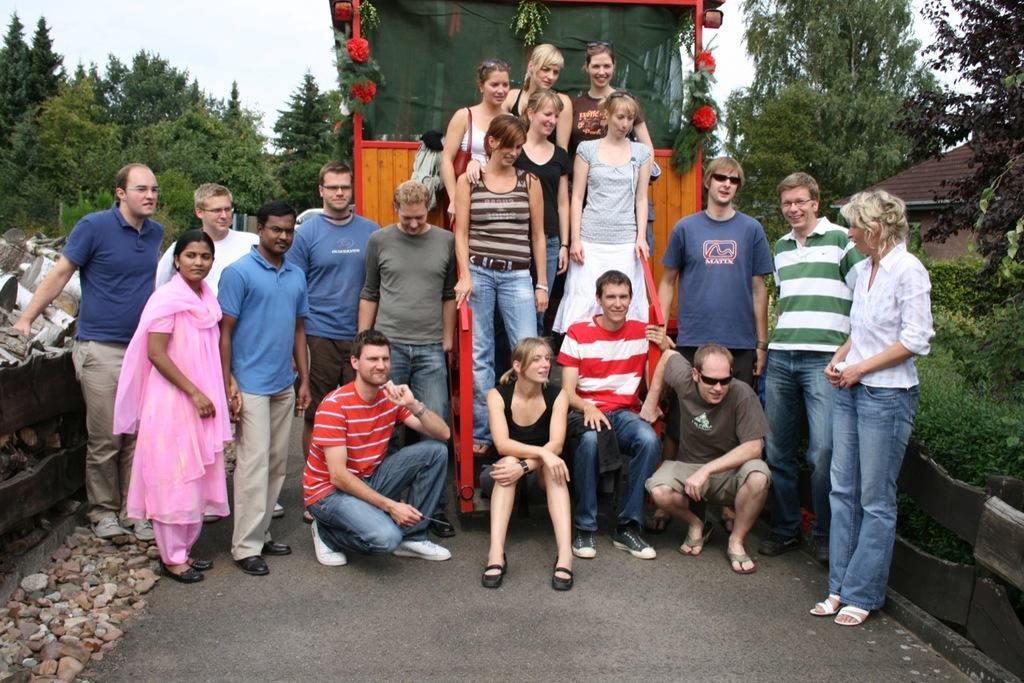Can you describe this image briefly? In this image I can see the number of people where few are sitting and rest all are standing. I can also see smile on few faces and I can see few of them are wearing shades. In the background I can see number of trees, a house, road, number of stones and a vehicle. 